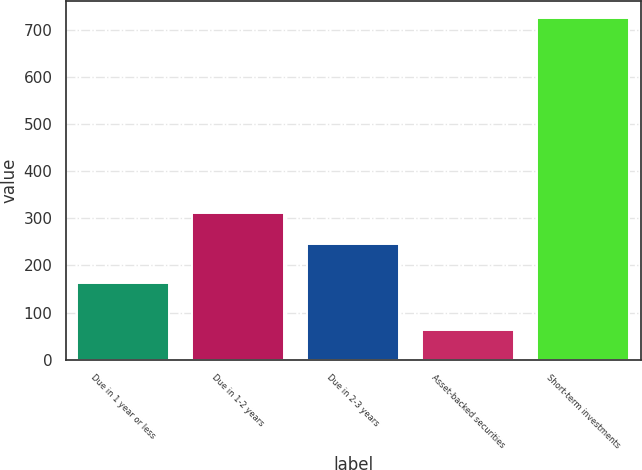<chart> <loc_0><loc_0><loc_500><loc_500><bar_chart><fcel>Due in 1 year or less<fcel>Due in 1-2 years<fcel>Due in 2-3 years<fcel>Asset-backed securities<fcel>Short-term investments<nl><fcel>163<fcel>311.2<fcel>245<fcel>63<fcel>725<nl></chart> 